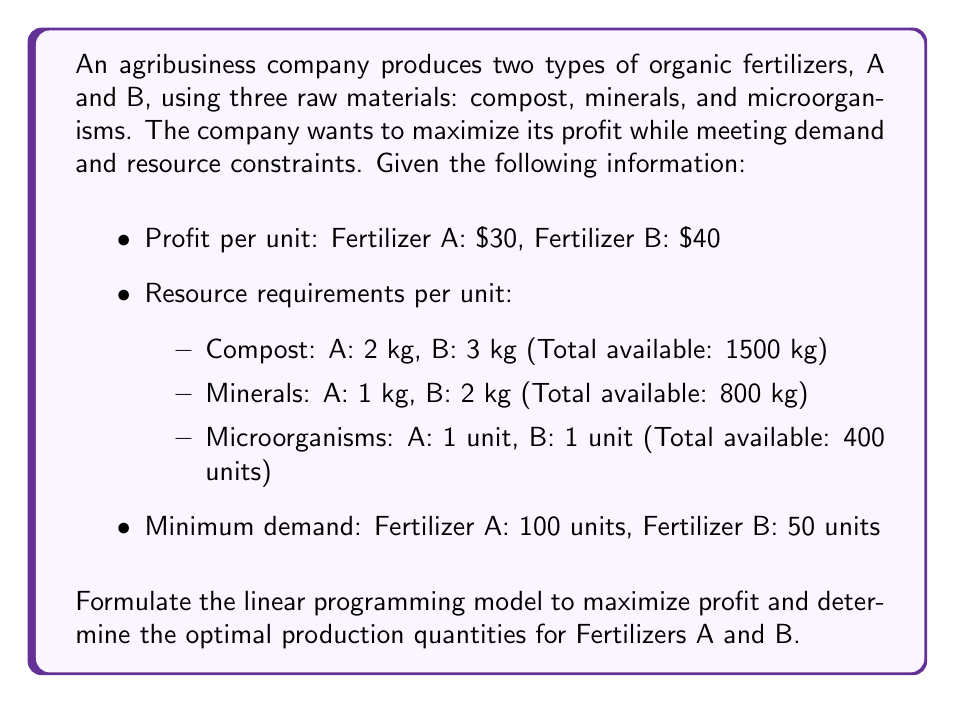Show me your answer to this math problem. To formulate the linear programming model, we need to define decision variables, an objective function, and constraints.

Step 1: Define decision variables
Let $x_A$ = number of units of Fertilizer A produced
Let $x_B$ = number of units of Fertilizer B produced

Step 2: Formulate the objective function
Maximize profit: $Z = 30x_A + 40x_B$

Step 3: Formulate the constraints

Resource constraints:
1. Compost: $2x_A + 3x_B \leq 1500$
2. Minerals: $x_A + 2x_B \leq 800$
3. Microorganisms: $x_A + x_B \leq 400$

Demand constraints:
4. Fertilizer A: $x_A \geq 100$
5. Fertilizer B: $x_B \geq 50$

Non-negativity constraints:
6. $x_A \geq 0$
7. $x_B \geq 0$

Step 4: Write the complete linear programming model

Maximize $Z = 30x_A + 40x_B$

Subject to:
$$\begin{align}
2x_A + 3x_B &\leq 1500 \\
x_A + 2x_B &\leq 800 \\
x_A + x_B &\leq 400 \\
x_A &\geq 100 \\
x_B &\geq 50 \\
x_A, x_B &\geq 0
\end{align}$$

This model can be solved using linear programming techniques such as the simplex method or by using optimization software.
Answer: Maximize $Z = 30x_A + 40x_B$ subject to constraints: $2x_A + 3x_B \leq 1500$, $x_A + 2x_B \leq 800$, $x_A + x_B \leq 400$, $x_A \geq 100$, $x_B \geq 50$, $x_A, x_B \geq 0$ 